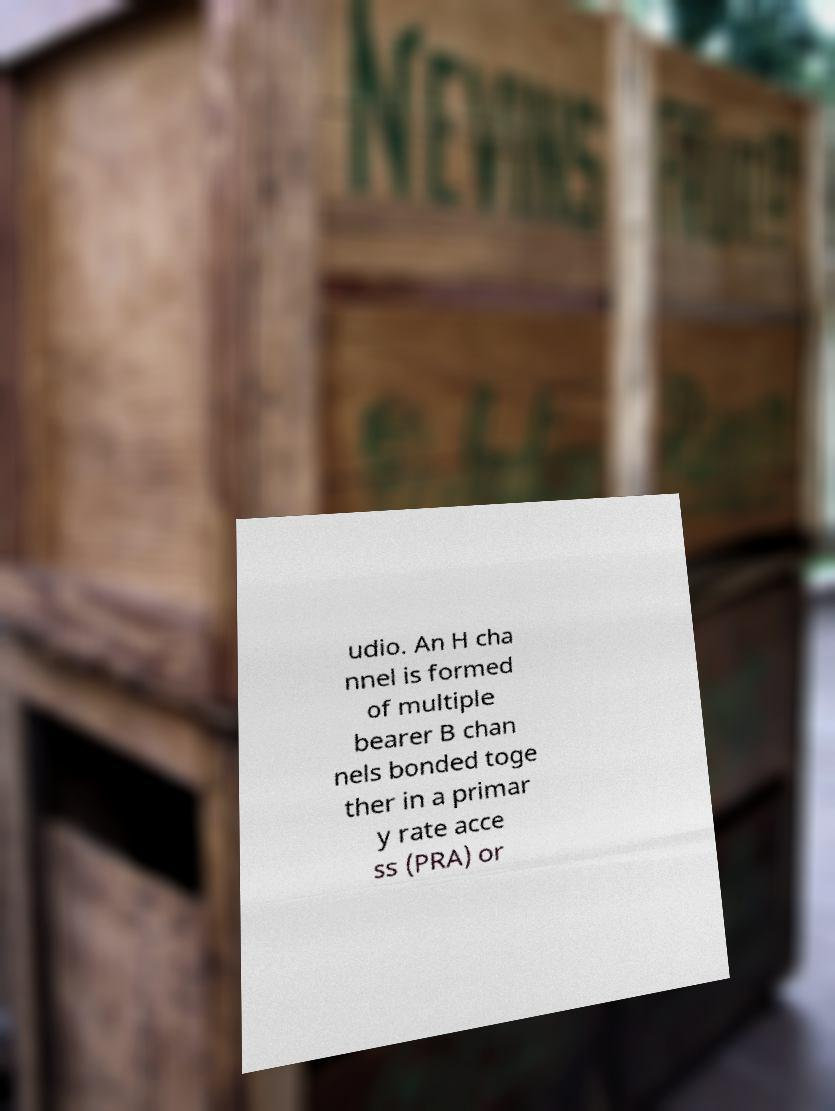Please identify and transcribe the text found in this image. udio. An H cha nnel is formed of multiple bearer B chan nels bonded toge ther in a primar y rate acce ss (PRA) or 